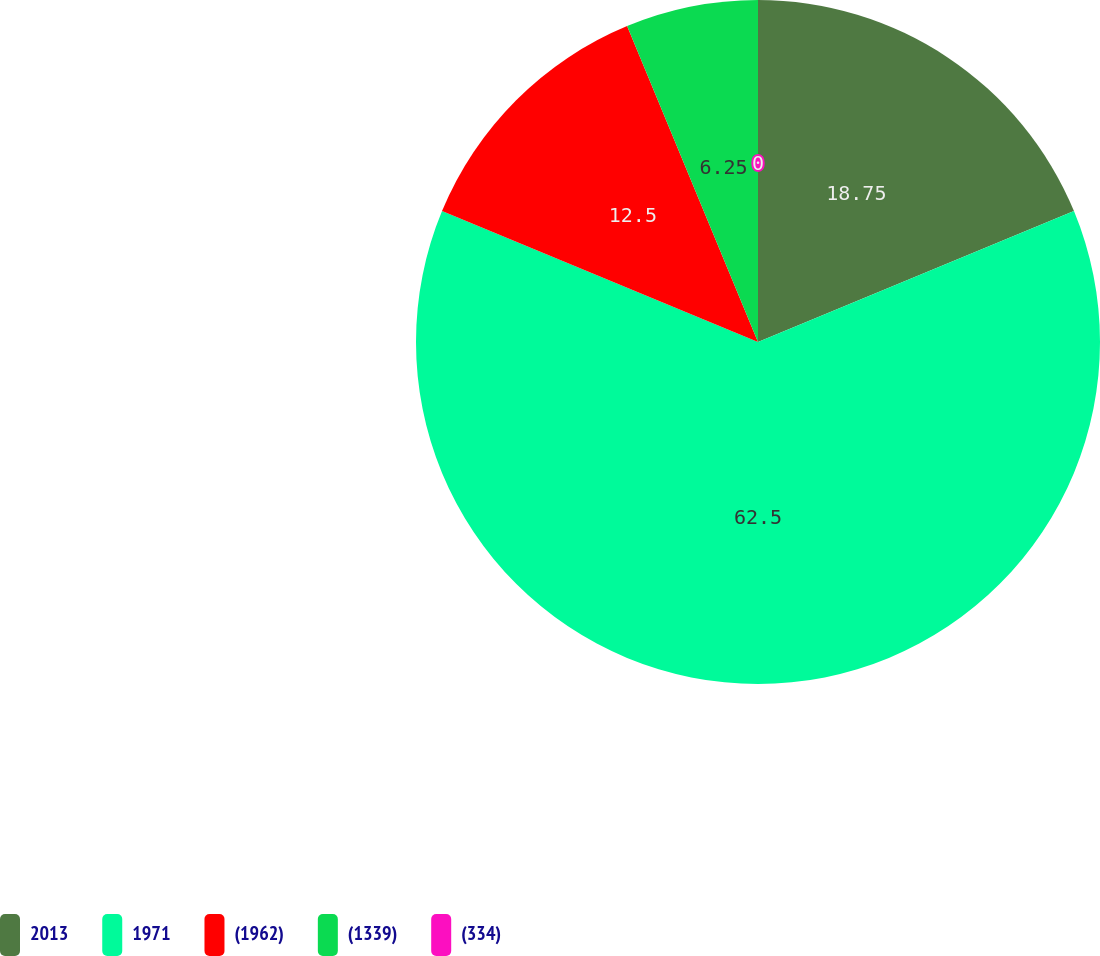Convert chart. <chart><loc_0><loc_0><loc_500><loc_500><pie_chart><fcel>2013<fcel>1971<fcel>(1962)<fcel>(1339)<fcel>(334)<nl><fcel>18.75%<fcel>62.5%<fcel>12.5%<fcel>6.25%<fcel>0.0%<nl></chart> 